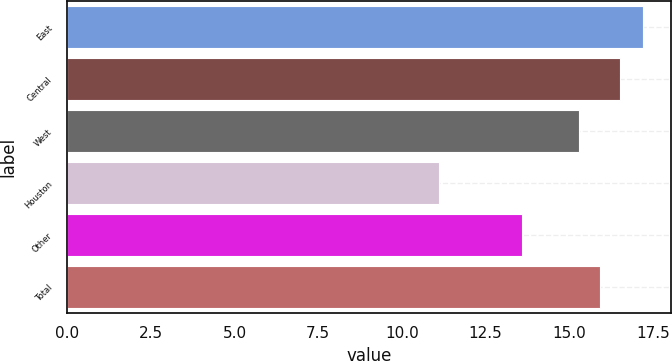<chart> <loc_0><loc_0><loc_500><loc_500><bar_chart><fcel>East<fcel>Central<fcel>West<fcel>Houston<fcel>Other<fcel>Total<nl><fcel>17.2<fcel>16.52<fcel>15.3<fcel>11.1<fcel>13.6<fcel>15.91<nl></chart> 